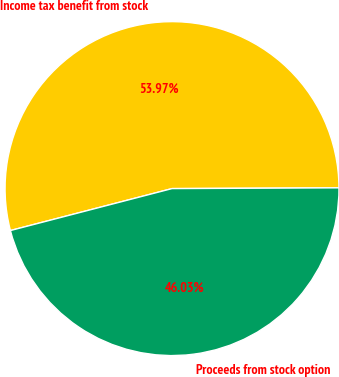Convert chart to OTSL. <chart><loc_0><loc_0><loc_500><loc_500><pie_chart><fcel>Income tax benefit from stock<fcel>Proceeds from stock option<nl><fcel>53.97%<fcel>46.03%<nl></chart> 